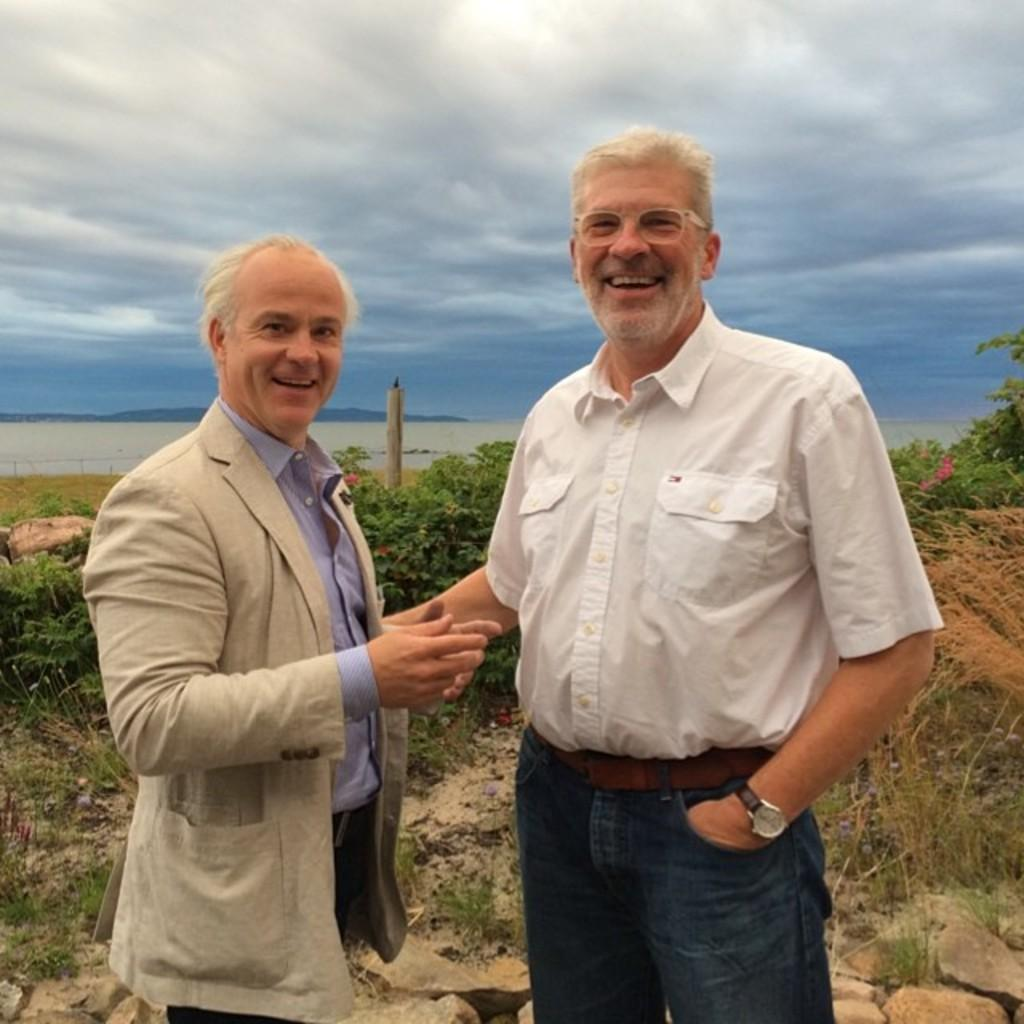What are the people in the image doing? The persons in the center of the image are standing and smiling. What can be seen in the background of the image? There are trees in the background of the image. What is the ground made of in the image? There is grass on the ground in the image. How would you describe the sky in the image? The sky is cloudy in the image. What type of cloth is being used to cover the committee in the image? There is no committee or cloth present in the image; it features persons standing and smiling in a natural setting. 